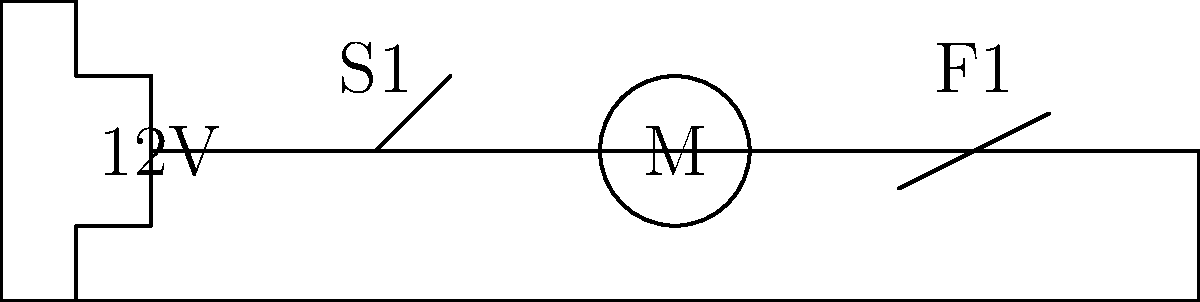You're designing a saltwater-resistant electrical system for your new fishing vessel. The schematic shows a 12V battery powering a motor through a switch (S1) and a fuse (F1). If the motor draws 5A of current under normal operation, what should be the minimum rating of the fuse F1 to ensure proper protection while avoiding nuisance tripping? To determine the appropriate fuse rating, we need to consider the following steps:

1. Understand the purpose of the fuse:
   The fuse is designed to protect the circuit from overcurrent conditions.

2. Consider the normal operating current:
   The motor draws 5A under normal operation.

3. Apply the 125% rule for continuous loads:
   Fuses should be rated at least 125% of the continuous load current to avoid nuisance tripping.
   Minimum fuse rating = 5A × 1.25 = 6.25A

4. Choose the next standard fuse size:
   Standard fuse sizes typically come in increments. The next standard size above 6.25A is usually 7A or 7.5A.

5. Consider environmental factors:
   In a marine environment, it's wise to add a small safety margin due to potential corrosion and harsh conditions.

6. Final recommendation:
   A 7.5A or 8A fuse would be appropriate, providing adequate protection while avoiding nuisance tripping.
Answer: 7.5A or 8A fuse 